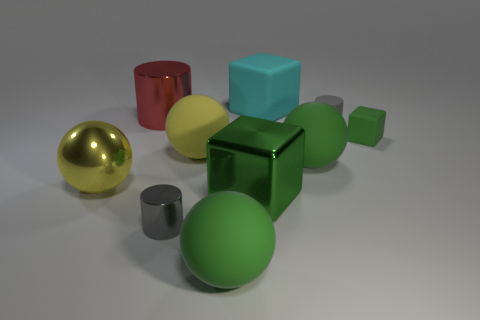Is the tiny rubber cube the same color as the shiny cube?
Your response must be concise. Yes. Are there more large green rubber objects that are to the left of the large cyan matte thing than big blue matte cubes?
Provide a succinct answer. Yes. The yellow metal object that is the same shape as the large yellow matte thing is what size?
Your answer should be compact. Large. What is the shape of the yellow matte thing?
Provide a short and direct response. Sphere. There is a green matte thing that is the same size as the gray metallic object; what shape is it?
Provide a short and direct response. Cube. Is there any other thing that has the same color as the big rubber block?
Provide a succinct answer. No. What size is the green block that is made of the same material as the big cyan thing?
Your answer should be very brief. Small. Do the gray matte thing and the green rubber thing that is left of the cyan object have the same shape?
Offer a very short reply. No. What size is the yellow matte thing?
Provide a succinct answer. Large. Is the number of gray metal cylinders right of the big cyan object less than the number of gray rubber things?
Make the answer very short. Yes. 